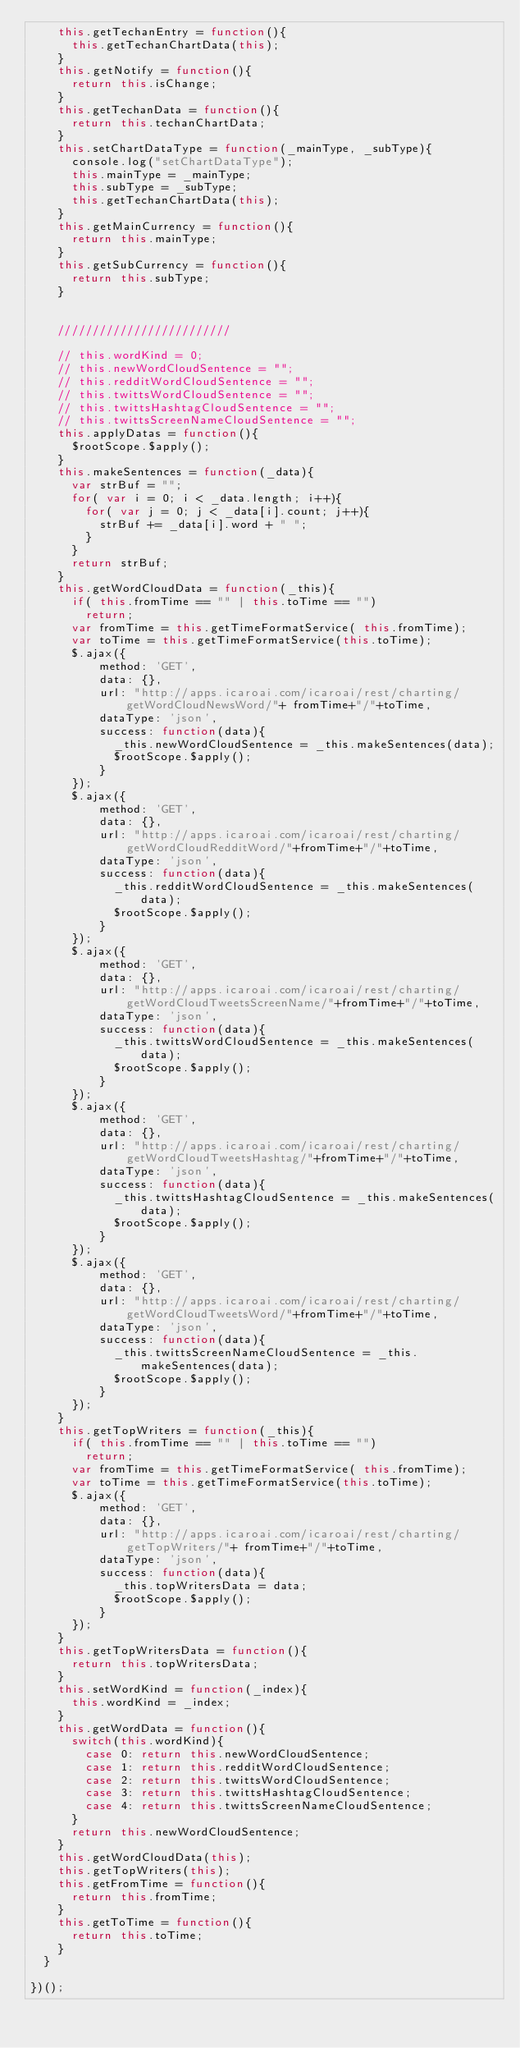<code> <loc_0><loc_0><loc_500><loc_500><_JavaScript_>    this.getTechanEntry = function(){
      this.getTechanChartData(this);
    }
    this.getNotify = function(){
      return this.isChange;
    }
    this.getTechanData = function(){
      return this.techanChartData;
    }
    this.setChartDataType = function(_mainType, _subType){
      console.log("setChartDataType");
      this.mainType = _mainType;
      this.subType = _subType;
      this.getTechanChartData(this);
    }
    this.getMainCurrency = function(){
      return this.mainType;
    }
    this.getSubCurrency = function(){
      return this.subType;
    }


    /////////////////////////

    // this.wordKind = 0;
    // this.newWordCloudSentence = "";
    // this.redditWordCloudSentence = "";
    // this.twittsWordCloudSentence = "";
    // this.twittsHashtagCloudSentence = "";
    // this.twittsScreenNameCloudSentence = "";
    this.applyDatas = function(){
      $rootScope.$apply();
    }
    this.makeSentences = function(_data){
      var strBuf = "";
      for( var i = 0; i < _data.length; i++){
        for( var j = 0; j < _data[i].count; j++){
          strBuf += _data[i].word + " ";
        }
      }
      return strBuf;
    }
    this.getWordCloudData = function(_this){
      if( this.fromTime == "" | this.toTime == "")
        return;
      var fromTime = this.getTimeFormatService( this.fromTime);
      var toTime = this.getTimeFormatService(this.toTime);
      $.ajax({
          method: 'GET',
          data: {},
          url: "http://apps.icaroai.com/icaroai/rest/charting/getWordCloudNewsWord/"+ fromTime+"/"+toTime,
          dataType: 'json',
          success: function(data){
            _this.newWordCloudSentence = _this.makeSentences(data);
            $rootScope.$apply();
          }
      });
      $.ajax({
          method: 'GET',
          data: {},
          url: "http://apps.icaroai.com/icaroai/rest/charting/getWordCloudRedditWord/"+fromTime+"/"+toTime,
          dataType: 'json',
          success: function(data){
            _this.redditWordCloudSentence = _this.makeSentences(data);
            $rootScope.$apply();
          }
      });
      $.ajax({
          method: 'GET',
          data: {},
          url: "http://apps.icaroai.com/icaroai/rest/charting/getWordCloudTweetsScreenName/"+fromTime+"/"+toTime,
          dataType: 'json',
          success: function(data){
            _this.twittsWordCloudSentence = _this.makeSentences(data);
            $rootScope.$apply();
          }
      });
      $.ajax({
          method: 'GET',
          data: {},
          url: "http://apps.icaroai.com/icaroai/rest/charting/getWordCloudTweetsHashtag/"+fromTime+"/"+toTime,
          dataType: 'json',
          success: function(data){
            _this.twittsHashtagCloudSentence = _this.makeSentences(data);
            $rootScope.$apply();
          }
      });
      $.ajax({
          method: 'GET',
          data: {},
          url: "http://apps.icaroai.com/icaroai/rest/charting/getWordCloudTweetsWord/"+fromTime+"/"+toTime,
          dataType: 'json',
          success: function(data){
            _this.twittsScreenNameCloudSentence = _this.makeSentences(data);
            $rootScope.$apply();
          }
      });
    }
    this.getTopWriters = function(_this){
      if( this.fromTime == "" | this.toTime == "")
        return;
      var fromTime = this.getTimeFormatService( this.fromTime);
      var toTime = this.getTimeFormatService(this.toTime);
      $.ajax({
          method: 'GET',
          data: {},
          url: "http://apps.icaroai.com/icaroai/rest/charting/getTopWriters/"+ fromTime+"/"+toTime,
          dataType: 'json',
          success: function(data){
            _this.topWritersData = data;
            $rootScope.$apply();
          }
      });
    }
    this.getTopWritersData = function(){
      return this.topWritersData;
    }
    this.setWordKind = function(_index){
      this.wordKind = _index;
    }
    this.getWordData = function(){
      switch(this.wordKind){
        case 0: return this.newWordCloudSentence;
        case 1: return this.redditWordCloudSentence;
        case 2: return this.twittsWordCloudSentence;
        case 3: return this.twittsHashtagCloudSentence;
        case 4: return this.twittsScreenNameCloudSentence;
      }
      return this.newWordCloudSentence;
    }
    this.getWordCloudData(this);
    this.getTopWriters(this);
    this.getFromTime = function(){
      return this.fromTime;
    }
    this.getToTime = function(){
      return this.toTime;
    }
  }

})();
</code> 